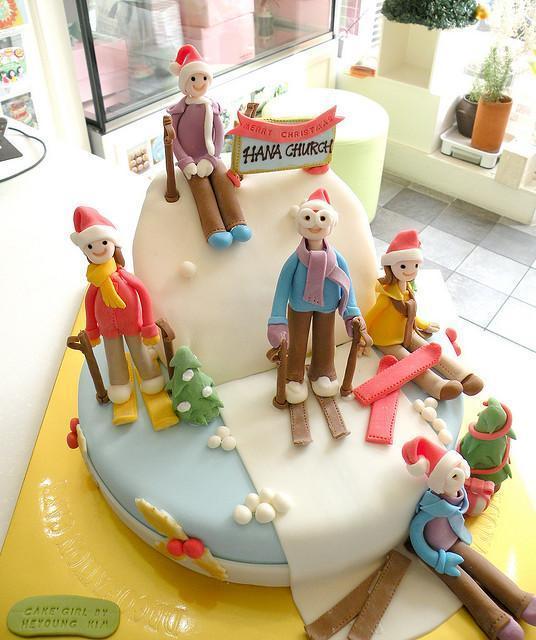How many potted plants are there?
Give a very brief answer. 2. How many ski are visible?
Give a very brief answer. 2. How many people are wearing a black shirt?
Give a very brief answer. 0. 